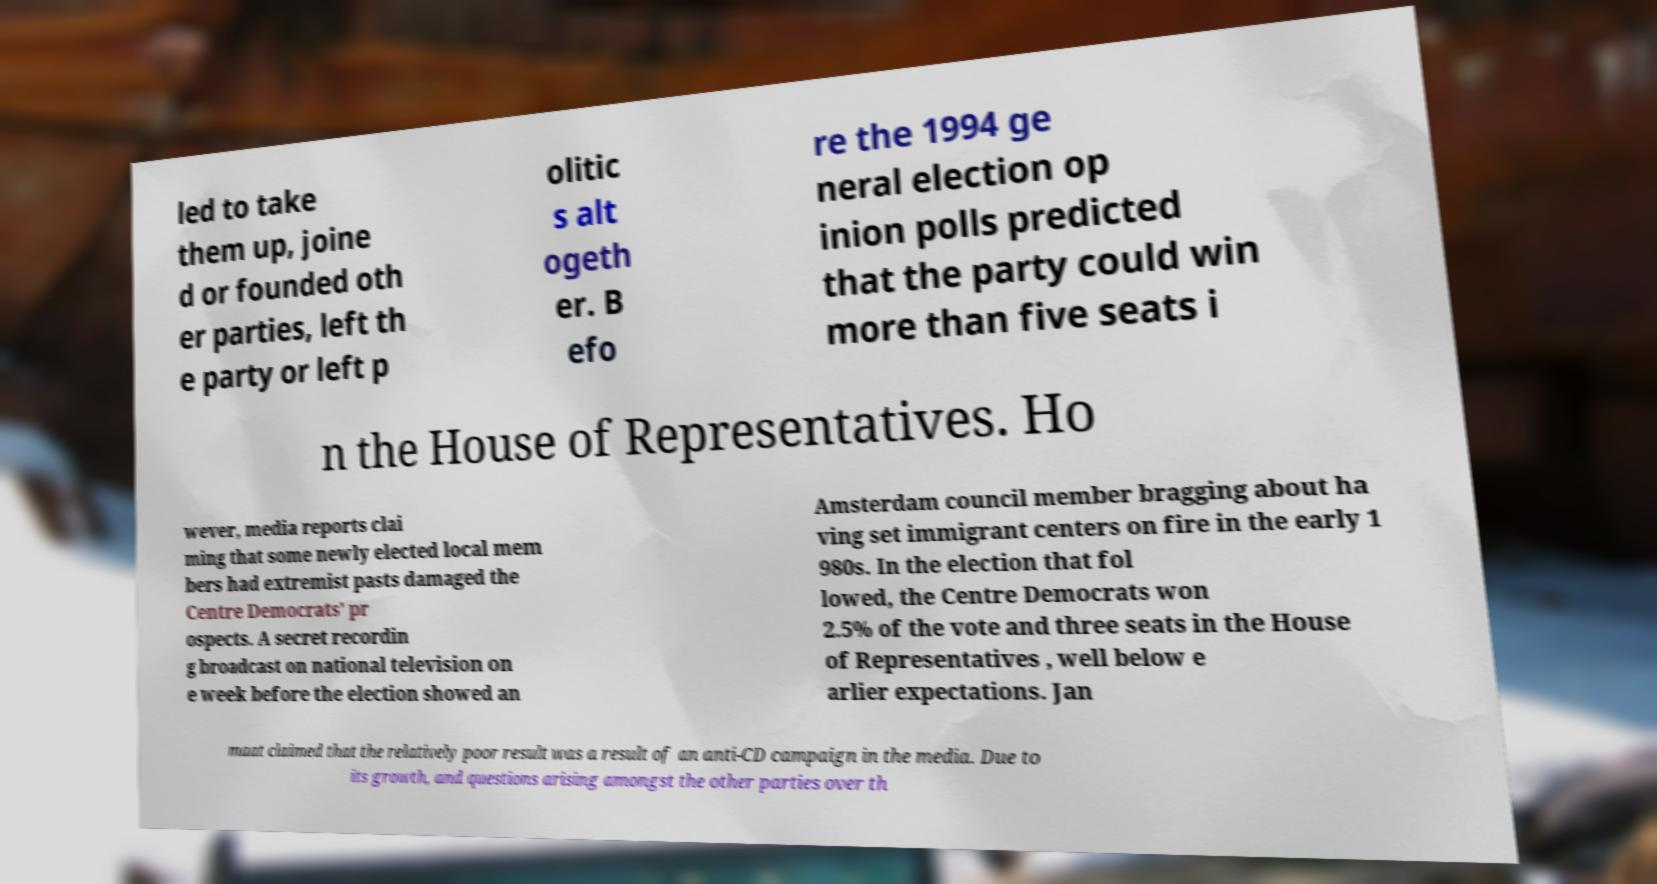For documentation purposes, I need the text within this image transcribed. Could you provide that? led to take them up, joine d or founded oth er parties, left th e party or left p olitic s alt ogeth er. B efo re the 1994 ge neral election op inion polls predicted that the party could win more than five seats i n the House of Representatives. Ho wever, media reports clai ming that some newly elected local mem bers had extremist pasts damaged the Centre Democrats' pr ospects. A secret recordin g broadcast on national television on e week before the election showed an Amsterdam council member bragging about ha ving set immigrant centers on fire in the early 1 980s. In the election that fol lowed, the Centre Democrats won 2.5% of the vote and three seats in the House of Representatives , well below e arlier expectations. Jan maat claimed that the relatively poor result was a result of an anti-CD campaign in the media. Due to its growth, and questions arising amongst the other parties over th 